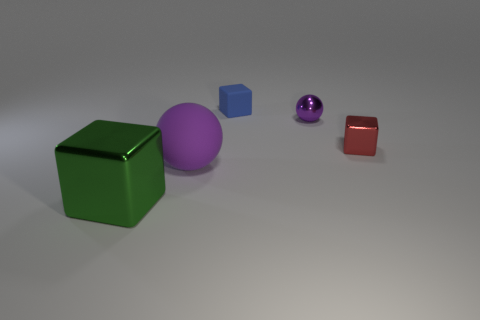Add 1 cylinders. How many objects exist? 6 Subtract all big green shiny blocks. How many blocks are left? 2 Subtract all red blocks. How many blocks are left? 2 Subtract 2 blocks. How many blocks are left? 1 Subtract all yellow cylinders. How many blue cubes are left? 1 Subtract all small blue matte objects. Subtract all blocks. How many objects are left? 1 Add 3 rubber objects. How many rubber objects are left? 5 Add 2 small rubber objects. How many small rubber objects exist? 3 Subtract 0 cyan blocks. How many objects are left? 5 Subtract all blocks. How many objects are left? 2 